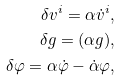<formula> <loc_0><loc_0><loc_500><loc_500>\delta v ^ { i } = \alpha \dot { v } ^ { i } , \\ \delta g = ( \alpha g ) , \\ \delta \varphi = \alpha \dot { \varphi } - \dot { \alpha } \varphi ,</formula> 